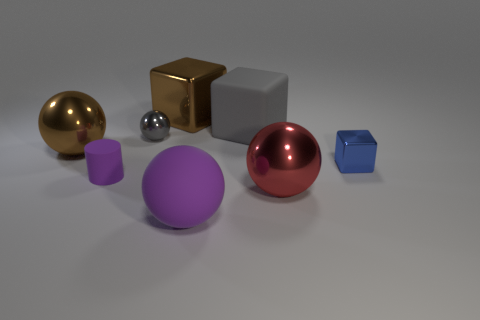Subtract all yellow spheres. Subtract all gray cubes. How many spheres are left? 4 Add 1 brown shiny cubes. How many objects exist? 9 Subtract all blocks. How many objects are left? 5 Subtract 1 gray blocks. How many objects are left? 7 Subtract all red matte spheres. Subtract all brown shiny objects. How many objects are left? 6 Add 7 small gray metallic things. How many small gray metallic things are left? 8 Add 8 gray cubes. How many gray cubes exist? 9 